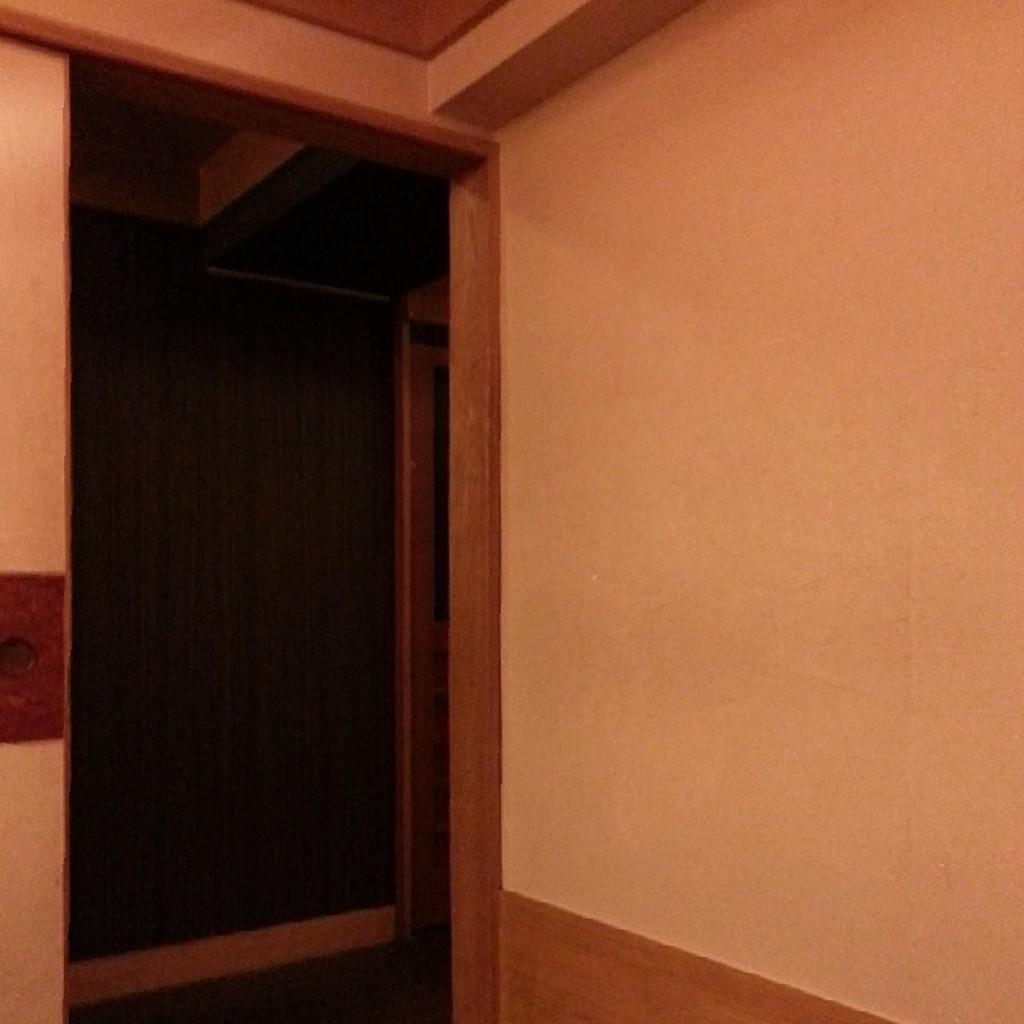In one or two sentences, can you explain what this image depicts? In this picture we can see the inside view of the room and in the front there is a door. 